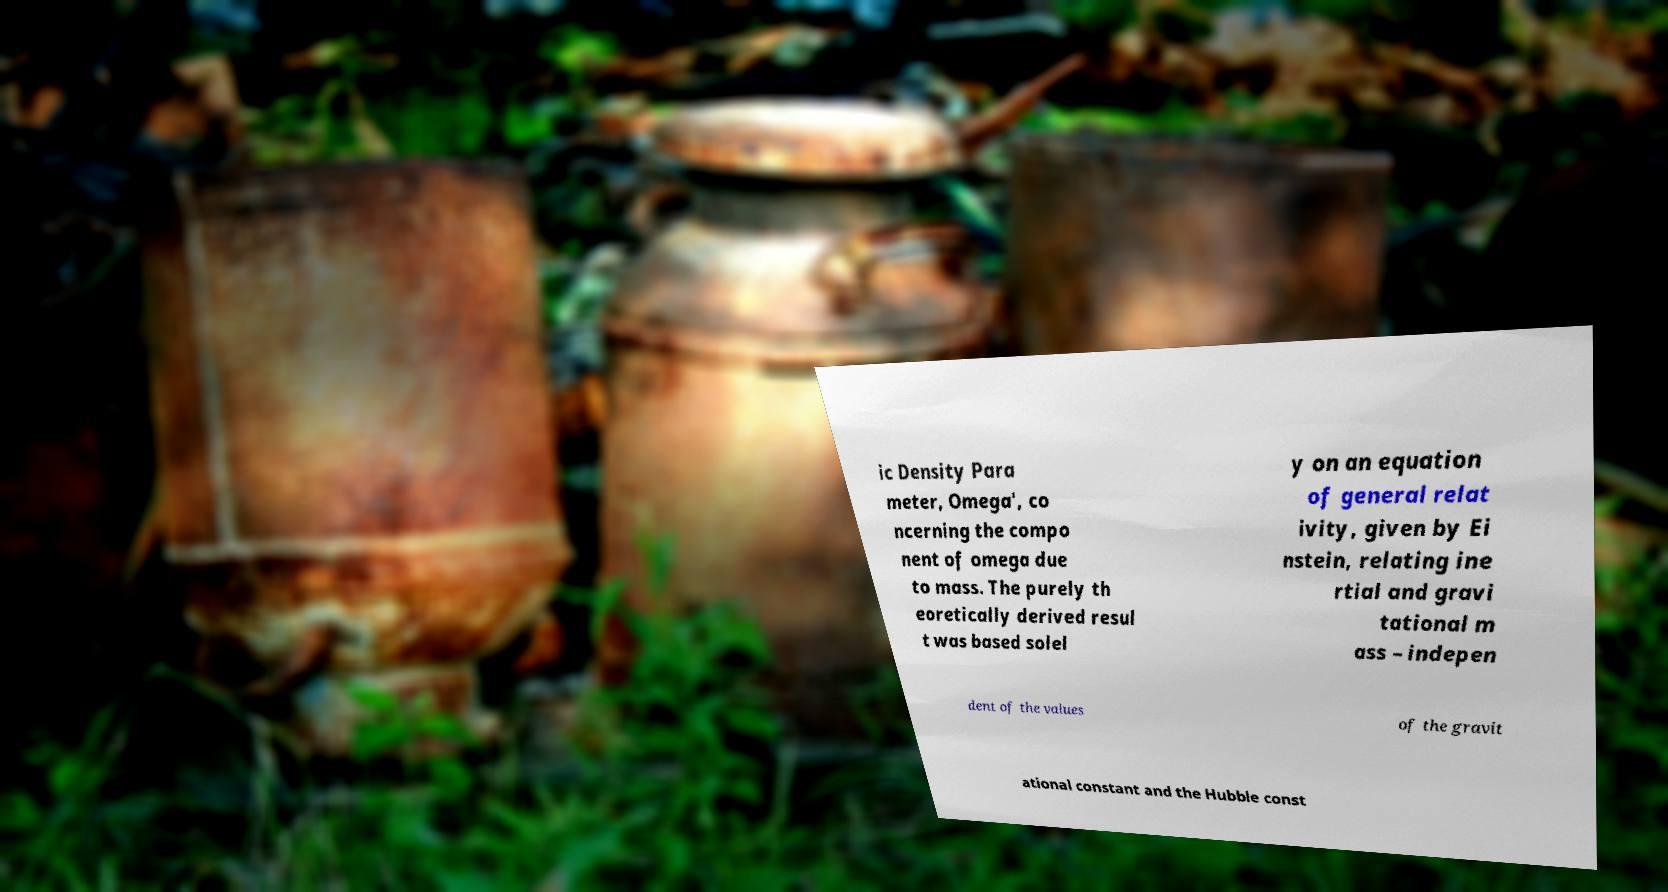Can you accurately transcribe the text from the provided image for me? ic Density Para meter, Omega', co ncerning the compo nent of omega due to mass. The purely th eoretically derived resul t was based solel y on an equation of general relat ivity, given by Ei nstein, relating ine rtial and gravi tational m ass – indepen dent of the values of the gravit ational constant and the Hubble const 